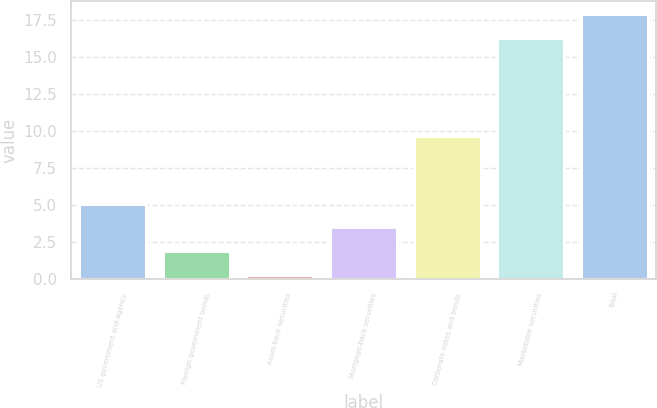Convert chart to OTSL. <chart><loc_0><loc_0><loc_500><loc_500><bar_chart><fcel>US government and agency<fcel>Foreign government bonds<fcel>Asset-back securities<fcel>Mortgage-back securities<fcel>Corporate notes and bonds<fcel>Marketable securities<fcel>Total<nl><fcel>5.1<fcel>1.9<fcel>0.3<fcel>3.5<fcel>9.7<fcel>16.3<fcel>17.9<nl></chart> 